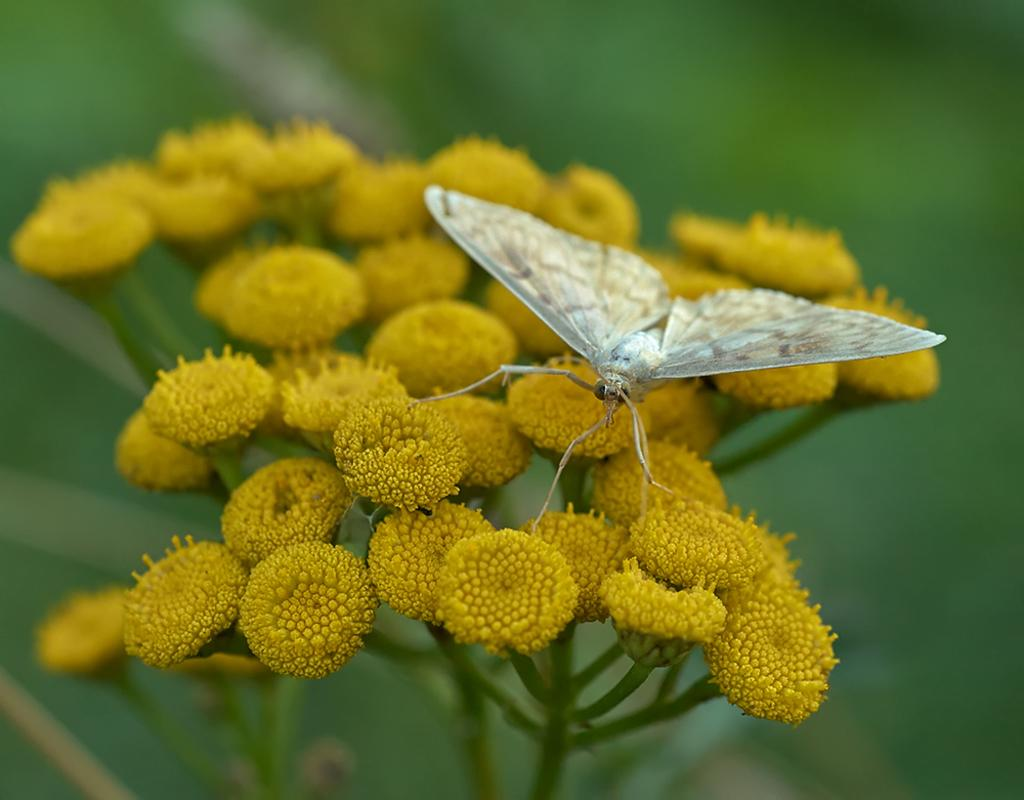What is the main subject of the image? There is a butterfly in the image. Where is the butterfly located in the image? The butterfly is on a flower. What type of camera can be seen in the image? There is no camera present in the image; it features a butterfly on a flower. How many rats are visible in the image? There are no rats present in the image. 